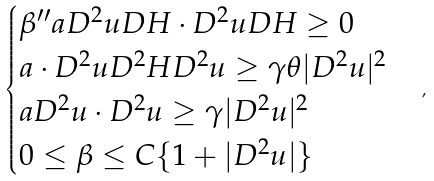Convert formula to latex. <formula><loc_0><loc_0><loc_500><loc_500>\begin{cases} \beta ^ { \prime \prime } a D ^ { 2 } u D H \cdot D ^ { 2 } u D H \geq 0 \\ a \cdot D ^ { 2 } u D ^ { 2 } H D ^ { 2 } u \geq \gamma \theta | D ^ { 2 } u | ^ { 2 } \\ a D ^ { 2 } u \cdot D ^ { 2 } u \geq \gamma | D ^ { 2 } u | ^ { 2 } \\ 0 \leq \beta \leq C \{ 1 + | D ^ { 2 } u | \} \end{cases} ,</formula> 